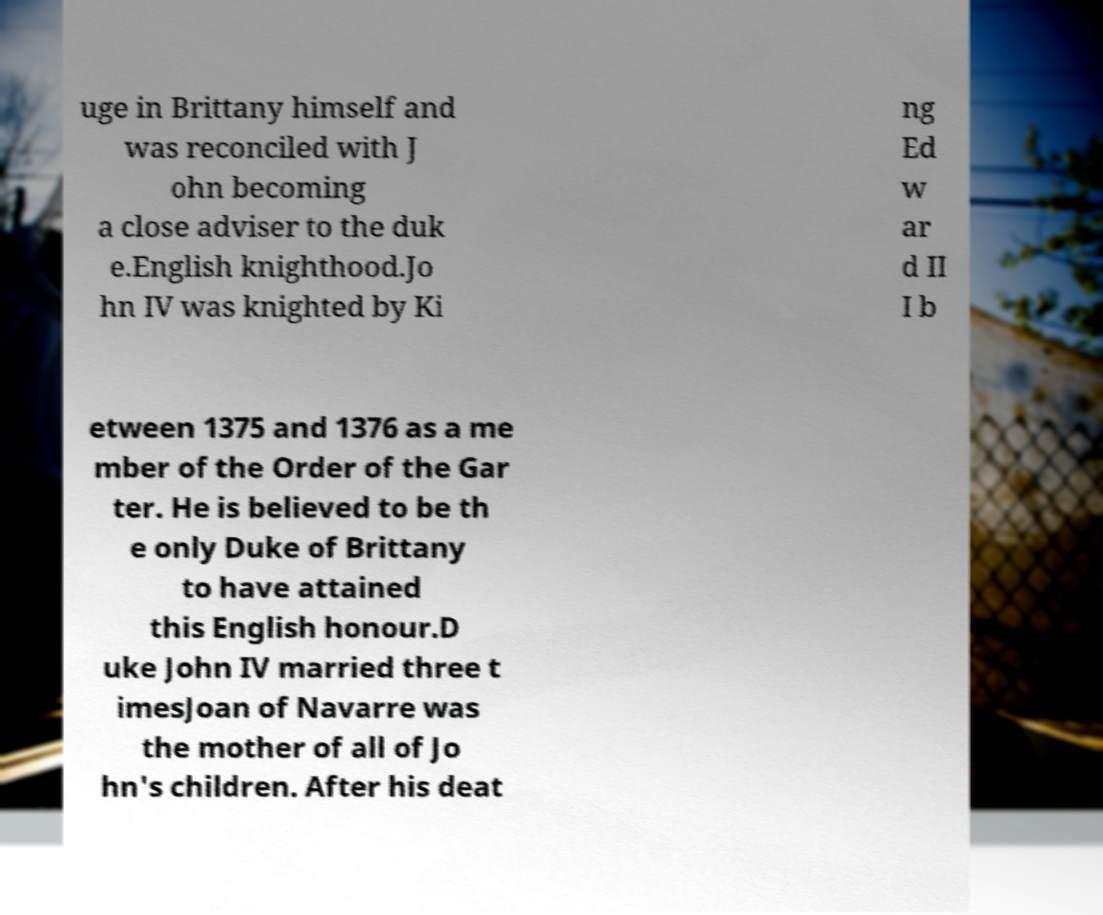Could you extract and type out the text from this image? uge in Brittany himself and was reconciled with J ohn becoming a close adviser to the duk e.English knighthood.Jo hn IV was knighted by Ki ng Ed w ar d II I b etween 1375 and 1376 as a me mber of the Order of the Gar ter. He is believed to be th e only Duke of Brittany to have attained this English honour.D uke John IV married three t imesJoan of Navarre was the mother of all of Jo hn's children. After his deat 